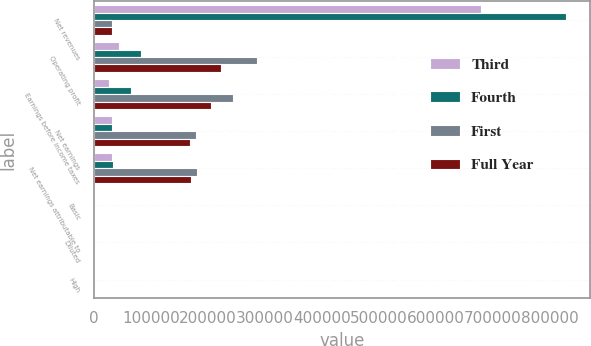<chart> <loc_0><loc_0><loc_500><loc_500><stacked_bar_chart><ecel><fcel>Net revenues<fcel>Operating profit<fcel>Earnings before income taxes<fcel>Net earnings<fcel>Net earnings attributable to<fcel>Basic<fcel>Diluted<fcel>High<nl><fcel>Third<fcel>679453<fcel>43448<fcel>25995<fcel>31514<fcel>32087<fcel>0.24<fcel>0.24<fcel>55.67<nl><fcel>Fourth<fcel>829262<fcel>82564<fcel>64517<fcel>32820<fcel>33475<fcel>0.26<fcel>0.26<fcel>56.91<nl><fcel>First<fcel>32453.5<fcel>285814<fcel>244054<fcel>180155<fcel>180457<fcel>1.42<fcel>1.4<fcel>55.78<nl><fcel>Full Year<fcel>32453.5<fcel>223549<fcel>205422<fcel>168821<fcel>169911<fcel>1.35<fcel>1.34<fcel>59.42<nl></chart> 